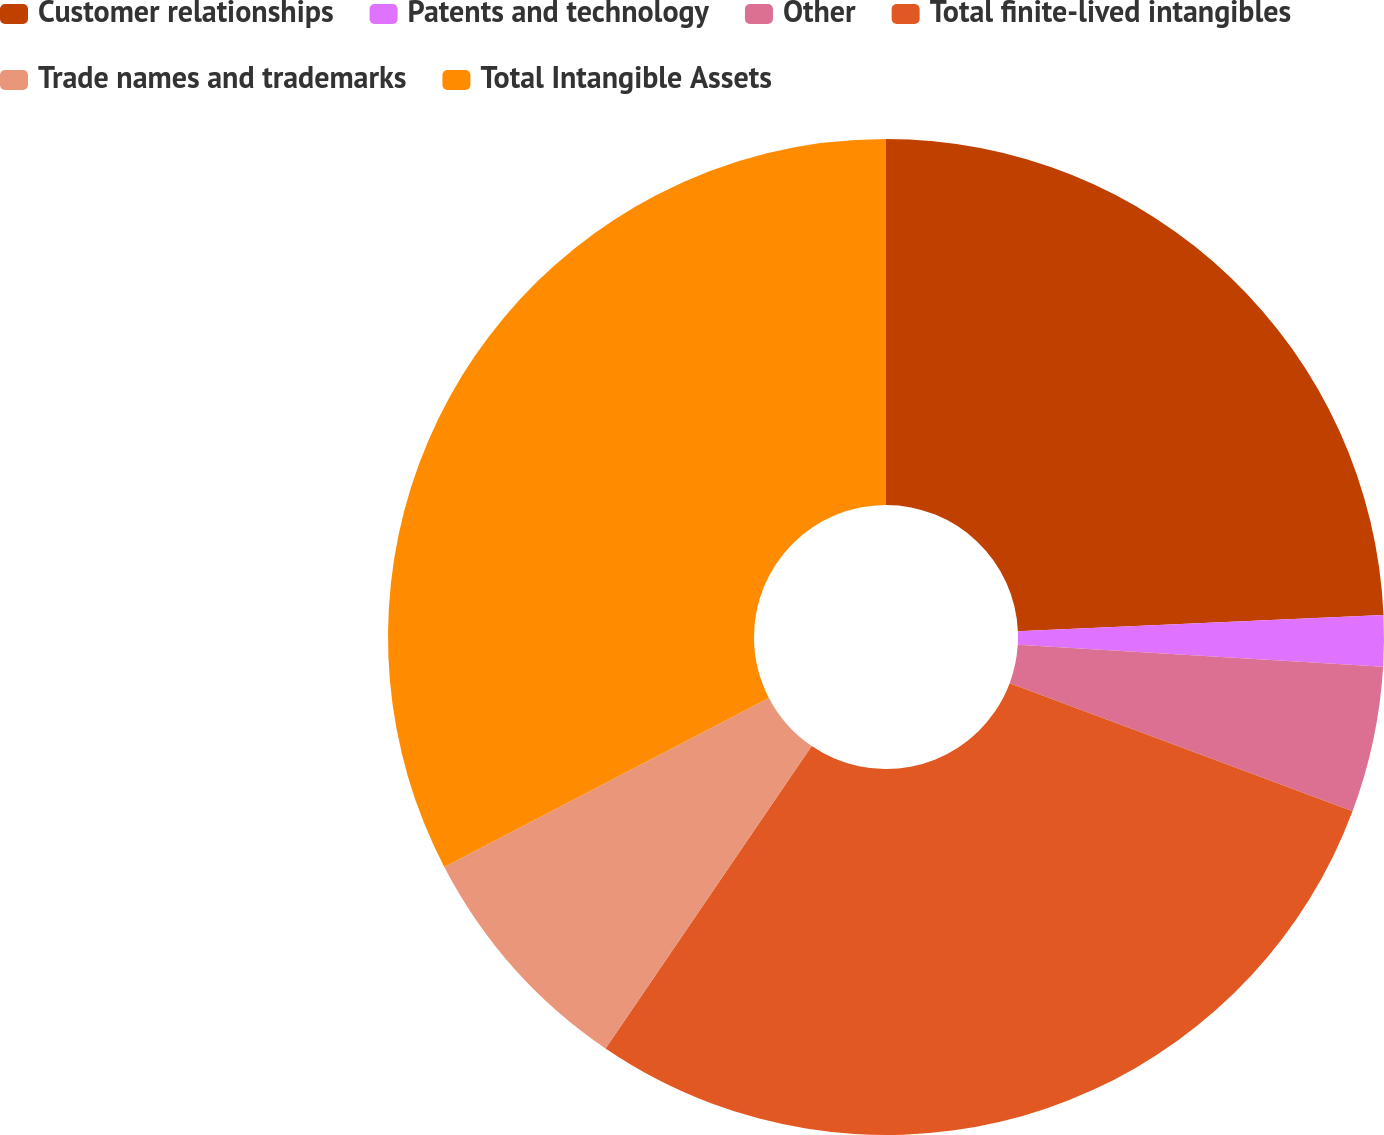<chart> <loc_0><loc_0><loc_500><loc_500><pie_chart><fcel>Customer relationships<fcel>Patents and technology<fcel>Other<fcel>Total finite-lived intangibles<fcel>Trade names and trademarks<fcel>Total Intangible Assets<nl><fcel>24.3%<fcel>1.65%<fcel>4.74%<fcel>28.83%<fcel>7.84%<fcel>32.64%<nl></chart> 